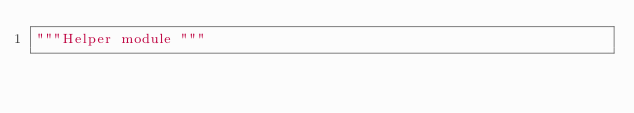<code> <loc_0><loc_0><loc_500><loc_500><_Python_>"""Helper module """
</code> 